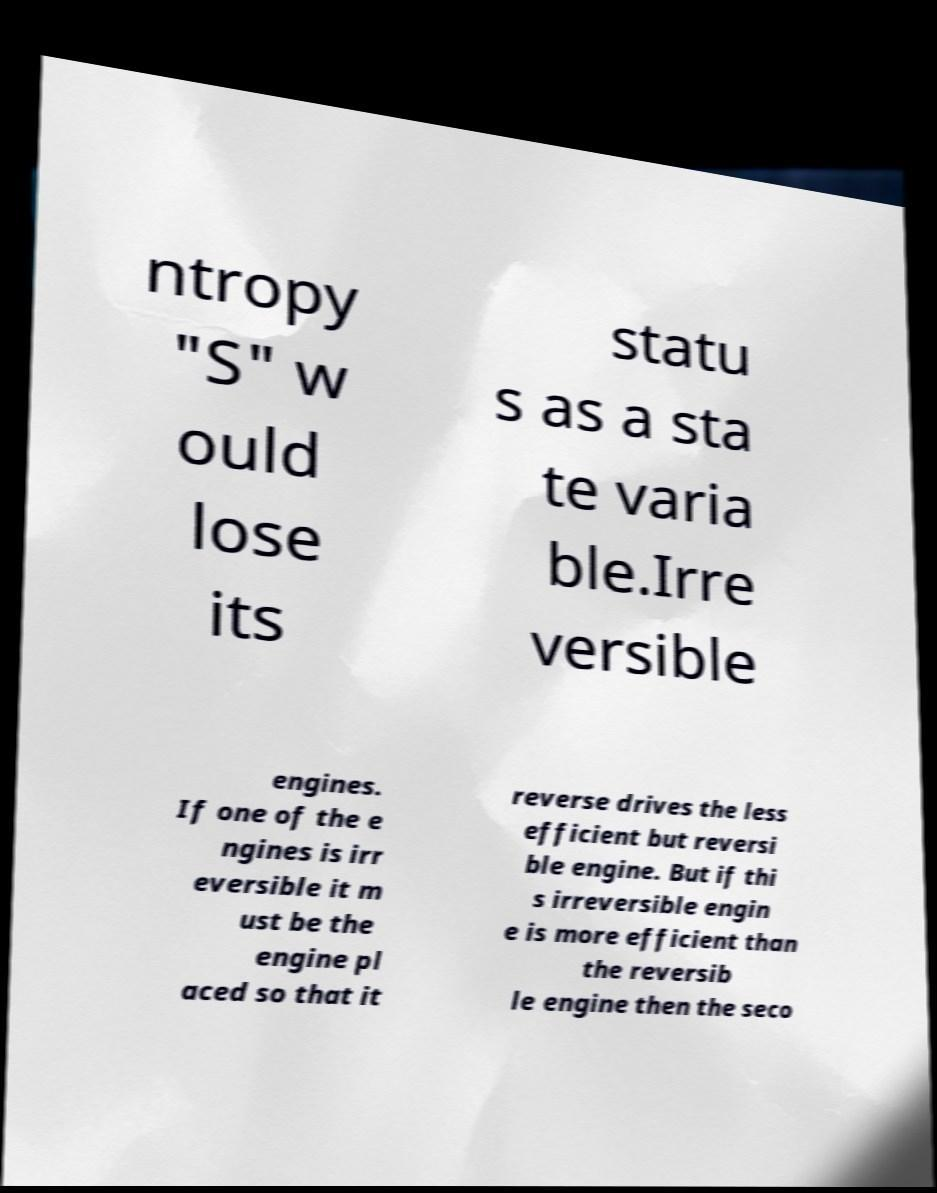Could you assist in decoding the text presented in this image and type it out clearly? ntropy "S" w ould lose its statu s as a sta te varia ble.Irre versible engines. If one of the e ngines is irr eversible it m ust be the engine pl aced so that it reverse drives the less efficient but reversi ble engine. But if thi s irreversible engin e is more efficient than the reversib le engine then the seco 